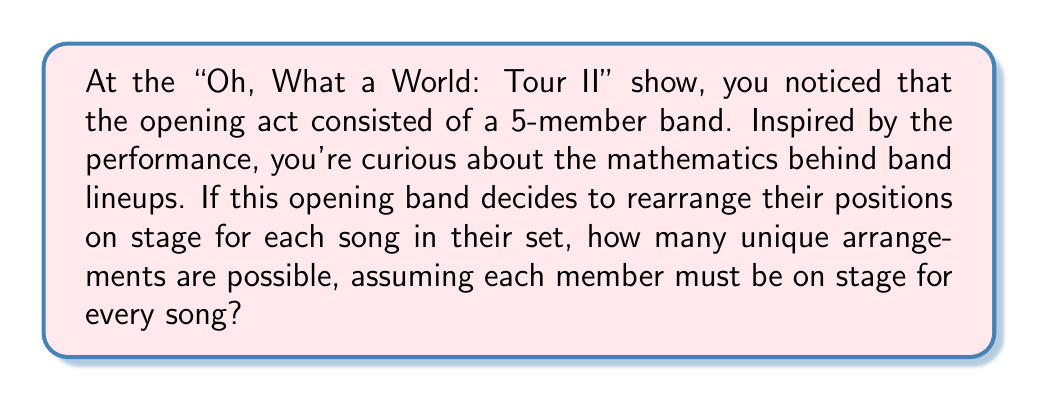Provide a solution to this math problem. To solve this problem, we need to use the concept of permutations from group theory. 

1) First, let's identify what we're dealing with:
   - We have 5 band members
   - Each arrangement must include all 5 members
   - The order of the members matters (their position on stage)

2) This scenario is a perfect application for permutations. The number of permutations of n distinct objects is given by n!

3) In this case, n = 5 (the number of band members)

4) Therefore, the number of possible arrangements is 5!

5) Let's calculate 5!:
   $$5! = 5 \times 4 \times 3 \times 2 \times 1 = 120$$

6) We can also think about this in terms of permutation groups:
   - The set of all permutations of 5 elements forms a symmetric group S_5
   - The order of S_5 (number of elements in the group) is 5!

7) Each unique arrangement corresponds to an element in S_5

Therefore, there are 120 possible unique arrangements for the 5-member band on stage.
Answer: 120 unique arrangements 